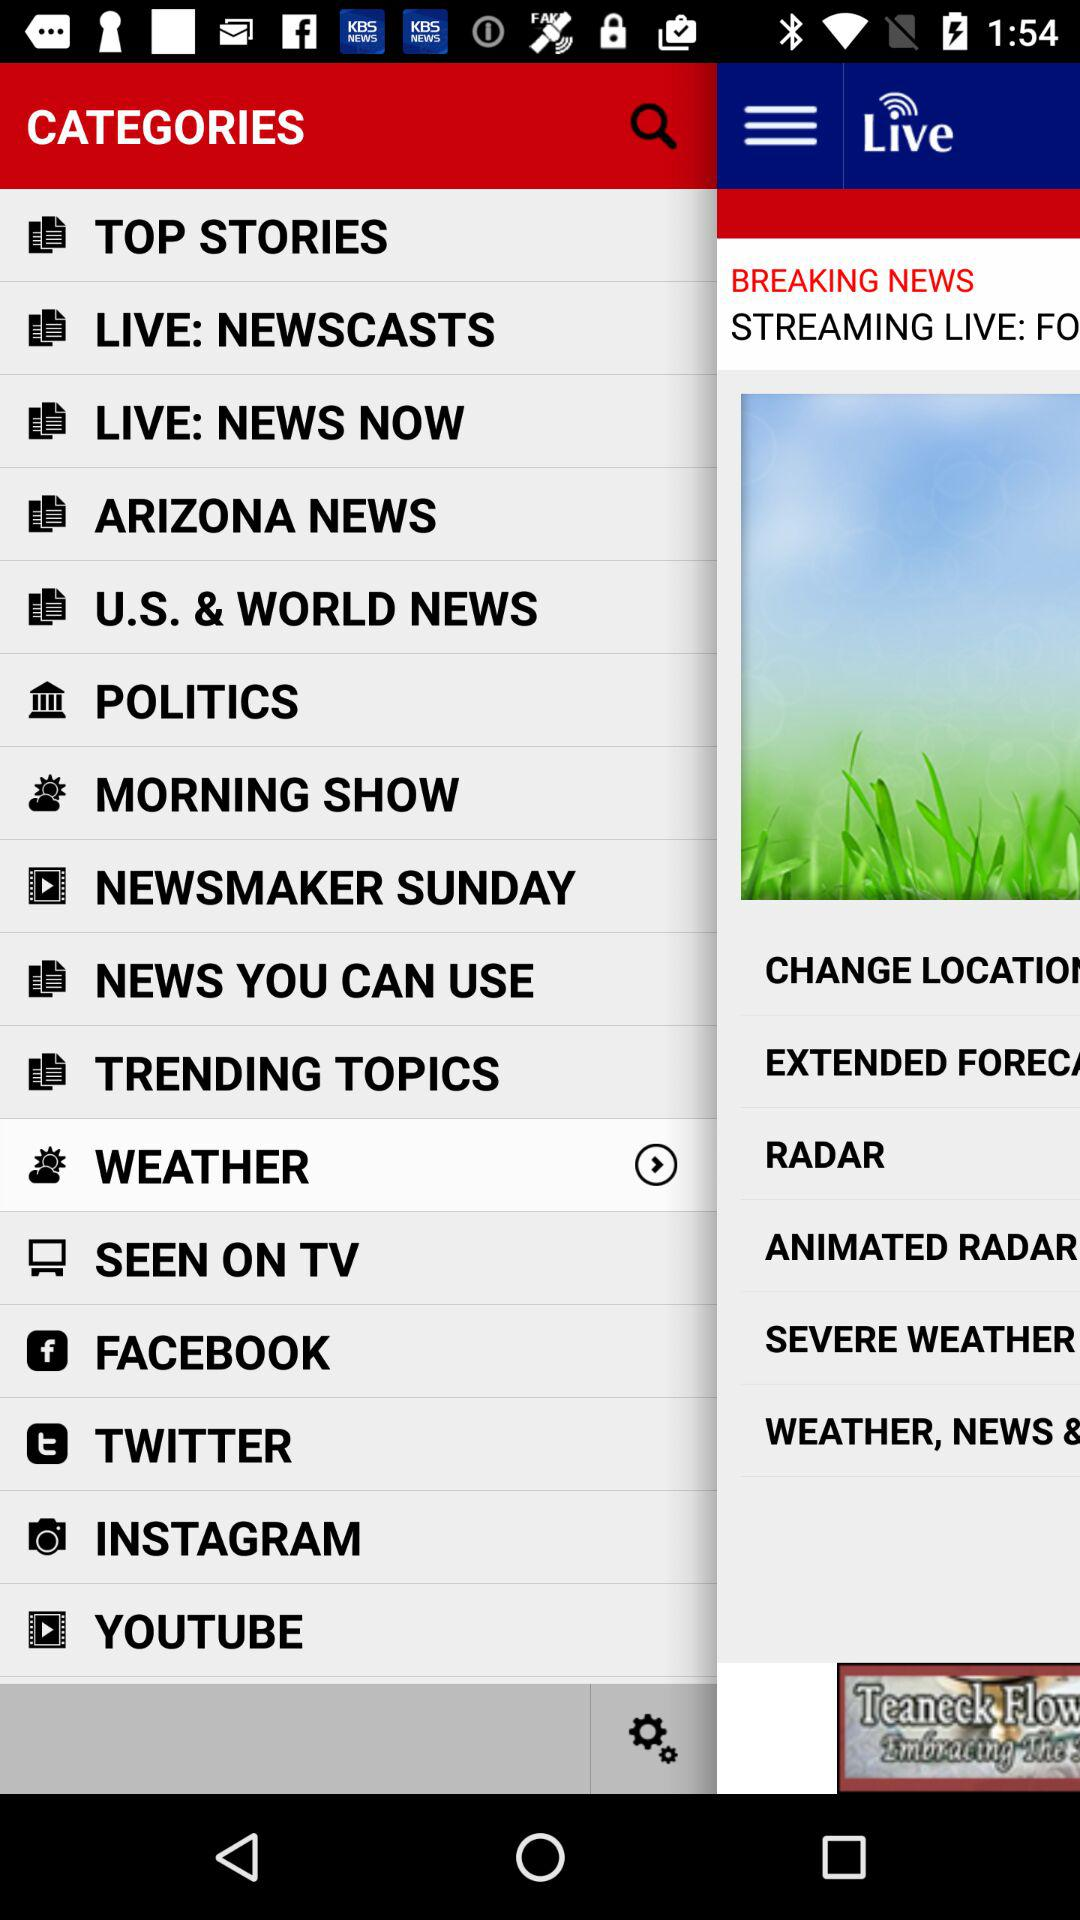Which item has been selected in the menu? The item "WEATHER" has been selected. 